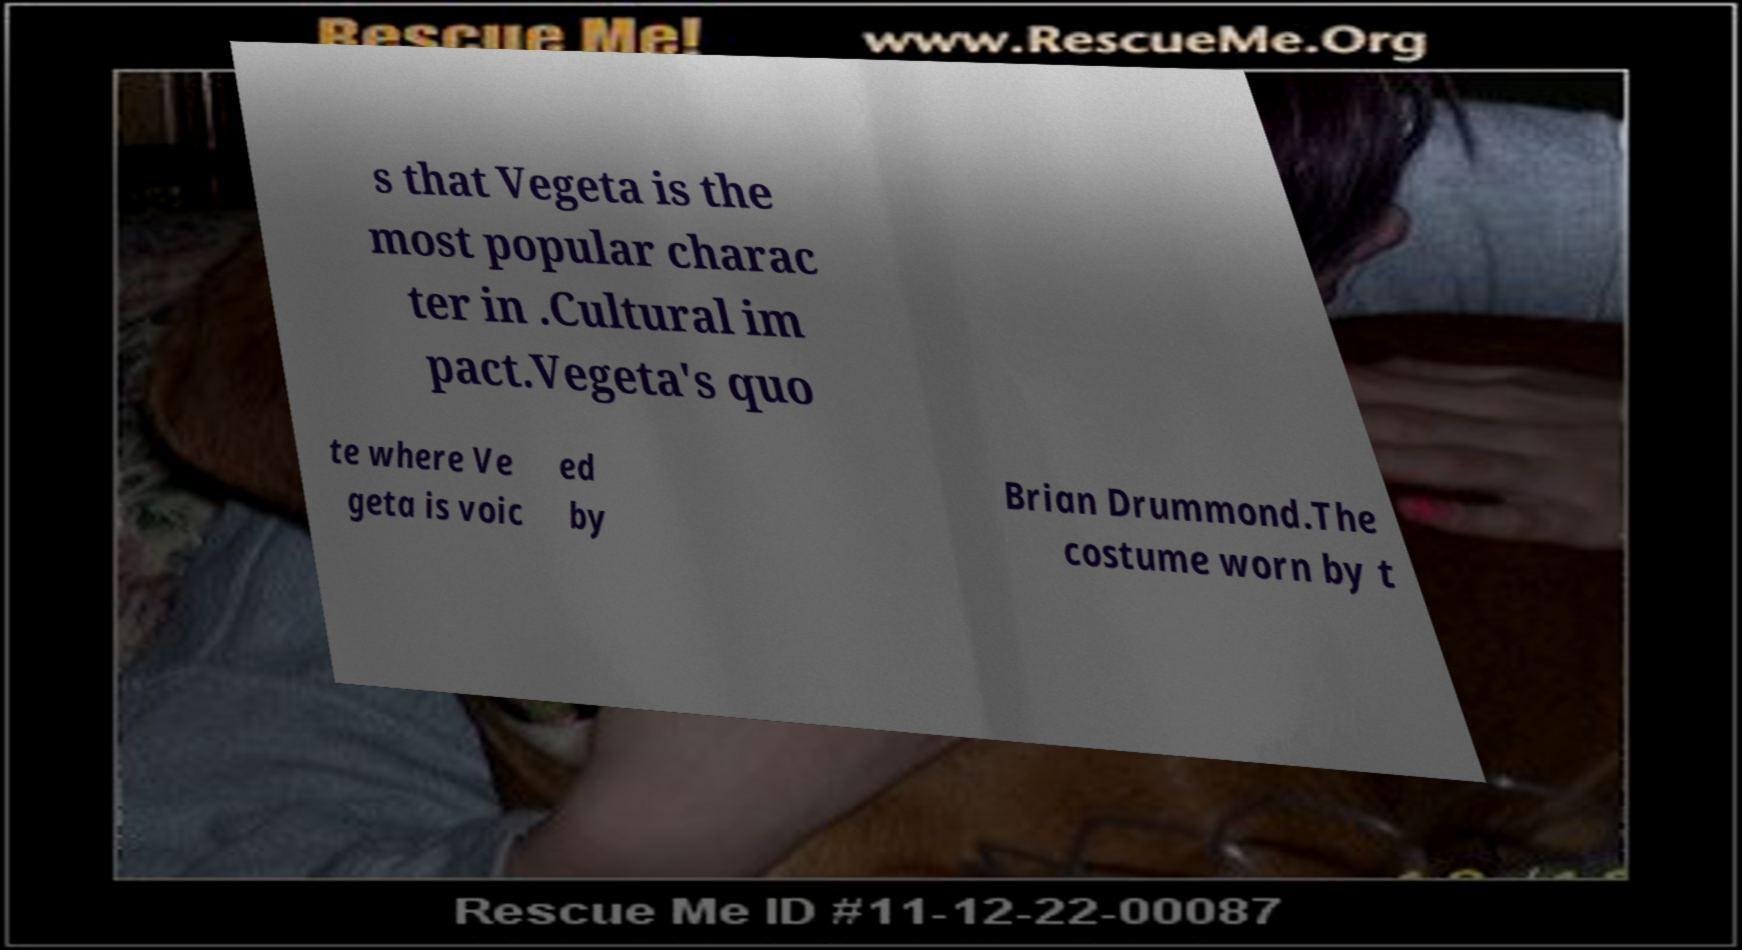For documentation purposes, I need the text within this image transcribed. Could you provide that? s that Vegeta is the most popular charac ter in .Cultural im pact.Vegeta's quo te where Ve geta is voic ed by Brian Drummond.The costume worn by t 